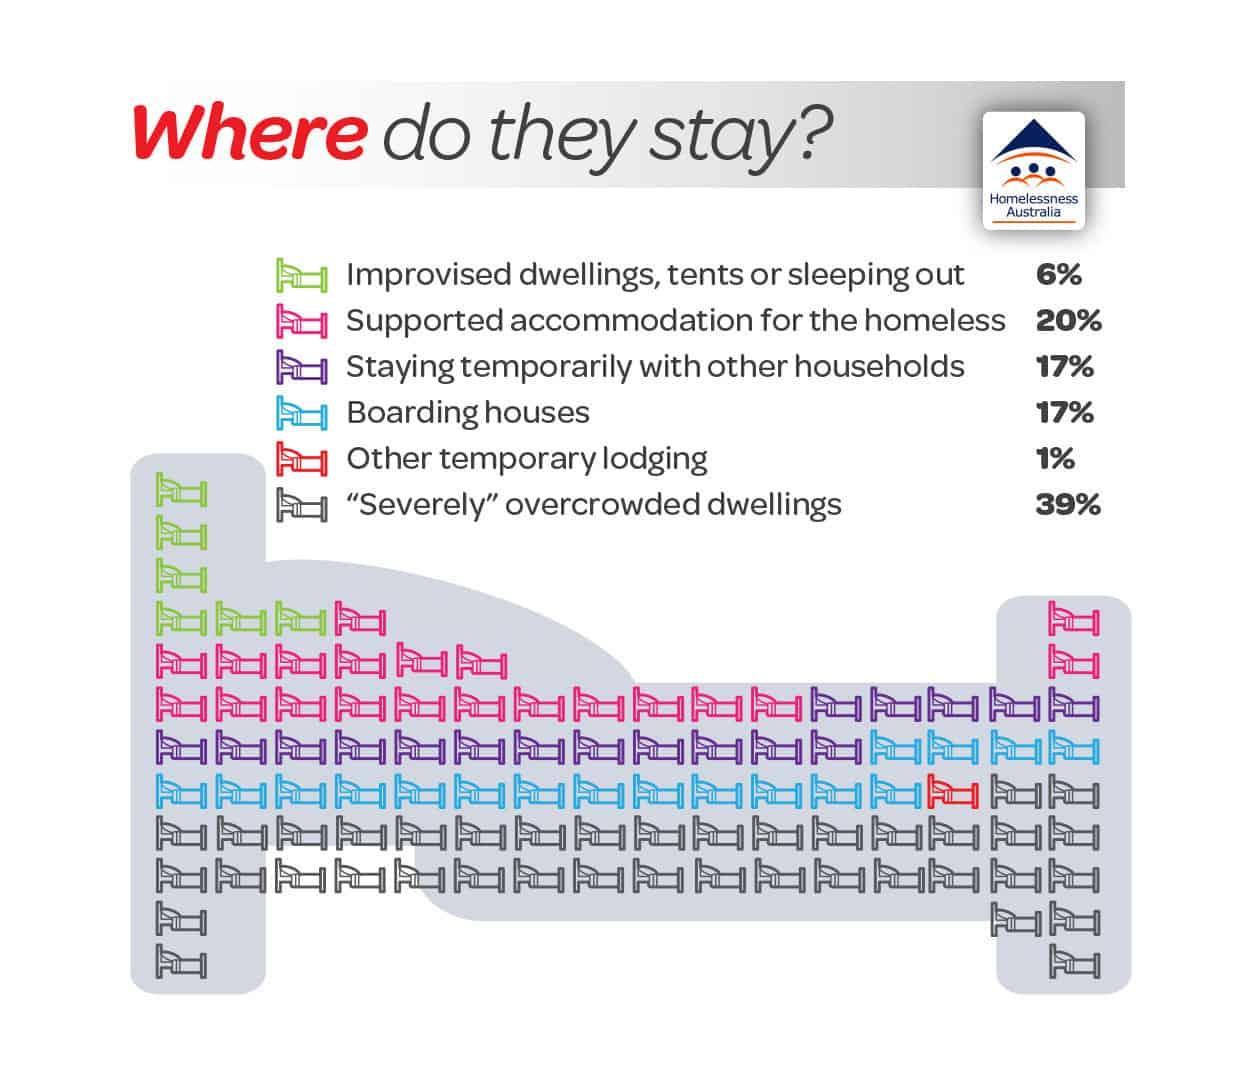Indicate a few pertinent items in this graphic. It is reported that Other temporary lodging is represented by the color red. The second highest percentage of population resides in supported accommodation for the homeless. The image shows a blue bed that represents boarding houses as a type of accommodation. Approximately 6% of the population stays in the type of accommodation denoted by a green bed. 